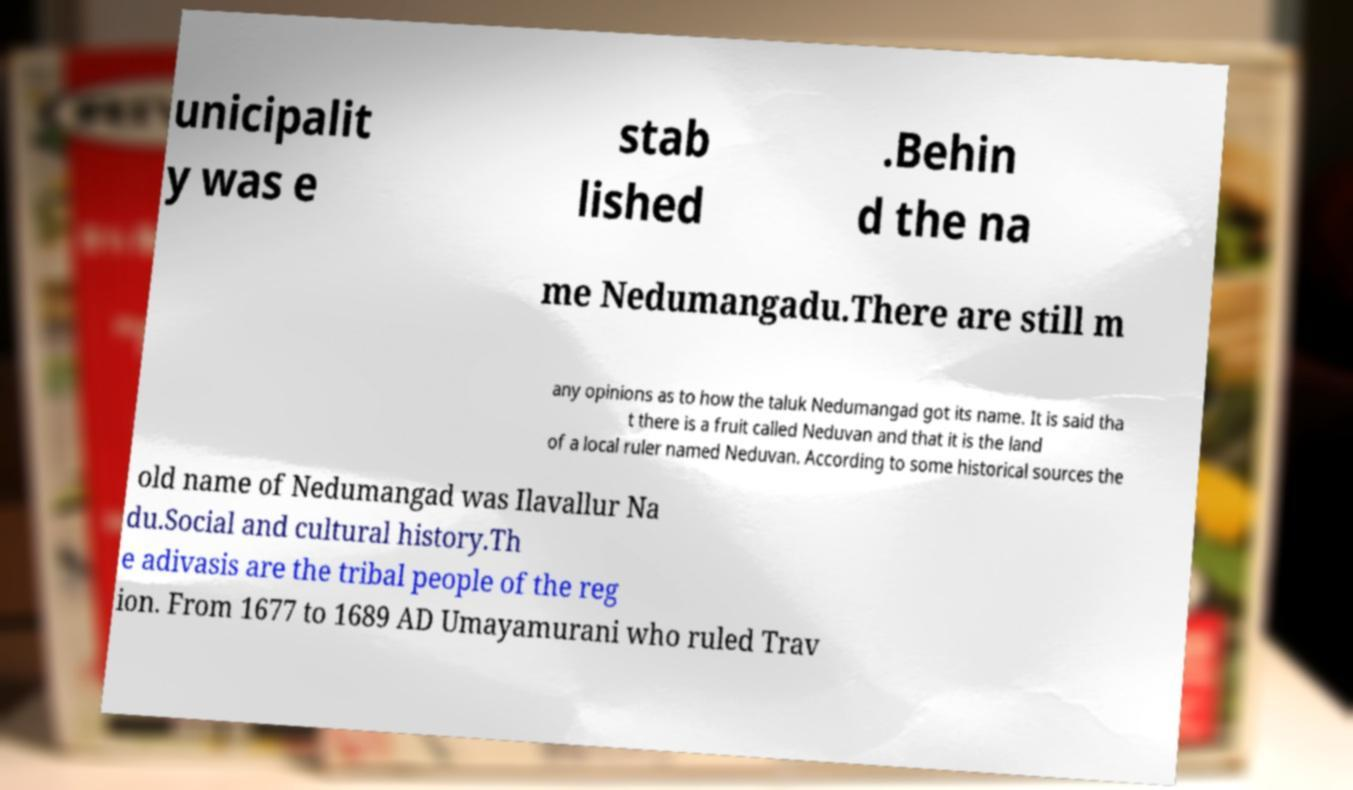I need the written content from this picture converted into text. Can you do that? unicipalit y was e stab lished .Behin d the na me Nedumangadu.There are still m any opinions as to how the taluk Nedumangad got its name. It is said tha t there is a fruit called Neduvan and that it is the land of a local ruler named Neduvan. According to some historical sources the old name of Nedumangad was Ilavallur Na du.Social and cultural history.Th e adivasis are the tribal people of the reg ion. From 1677 to 1689 AD Umayamurani who ruled Trav 